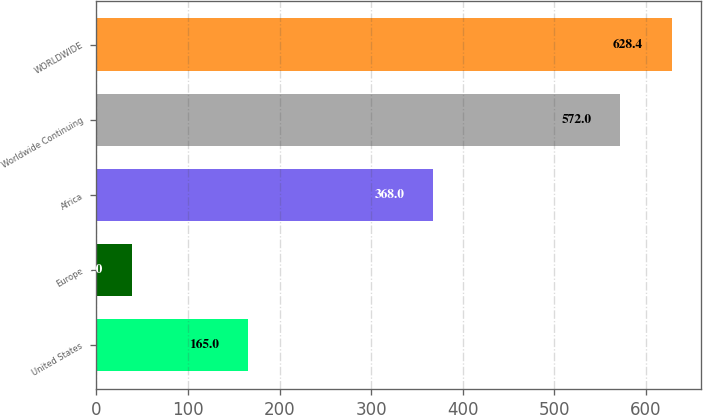Convert chart. <chart><loc_0><loc_0><loc_500><loc_500><bar_chart><fcel>United States<fcel>Europe<fcel>Africa<fcel>Worldwide Continuing<fcel>WORLDWIDE<nl><fcel>165<fcel>39<fcel>368<fcel>572<fcel>628.4<nl></chart> 